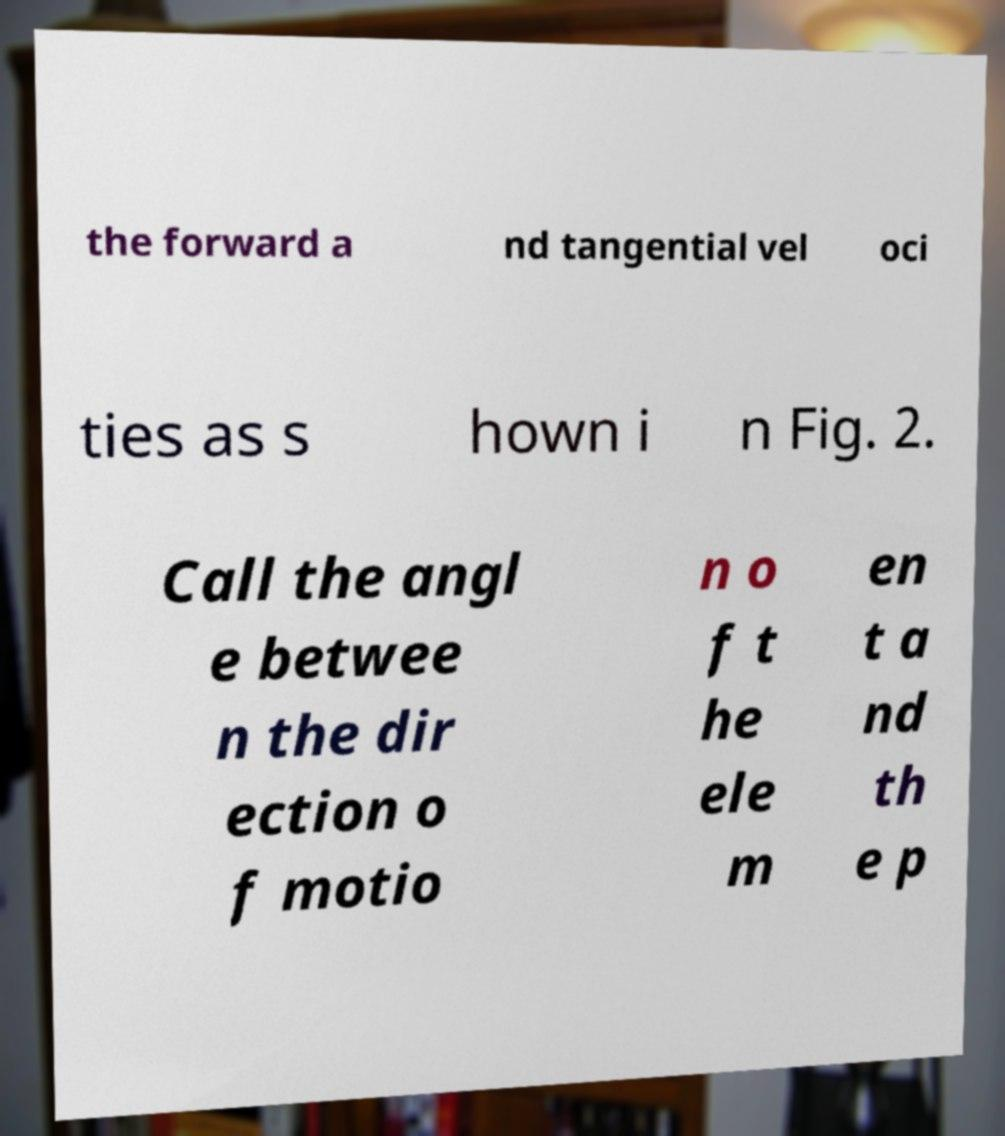There's text embedded in this image that I need extracted. Can you transcribe it verbatim? the forward a nd tangential vel oci ties as s hown i n Fig. 2. Call the angl e betwee n the dir ection o f motio n o f t he ele m en t a nd th e p 